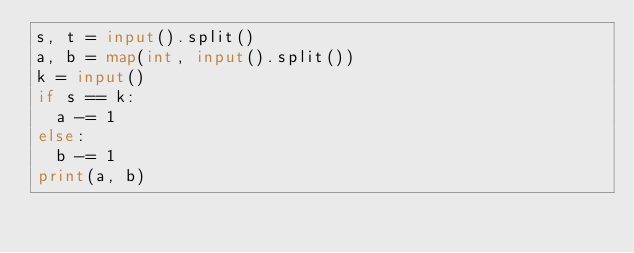Convert code to text. <code><loc_0><loc_0><loc_500><loc_500><_Python_>s, t = input().split()
a, b = map(int, input().split())
k = input()
if s == k:
  a -= 1
else:
  b -= 1
print(a, b)</code> 